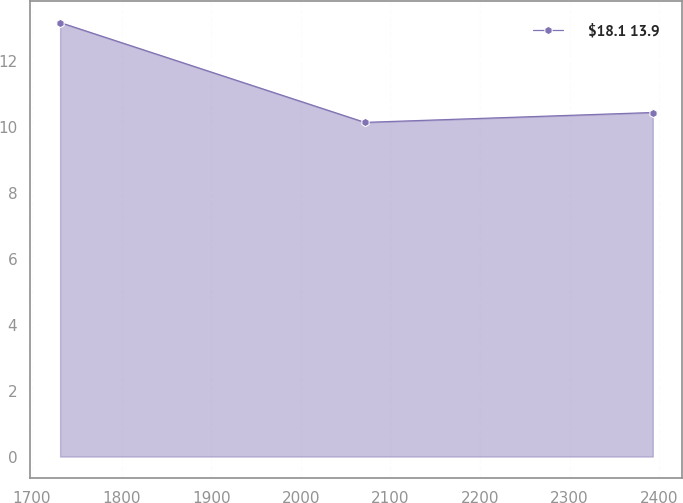Convert chart. <chart><loc_0><loc_0><loc_500><loc_500><line_chart><ecel><fcel>$18.1 13.9<nl><fcel>1731.41<fcel>13.17<nl><fcel>2071.56<fcel>10.14<nl><fcel>2392.91<fcel>10.44<nl></chart> 